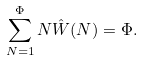<formula> <loc_0><loc_0><loc_500><loc_500>\sum _ { N = 1 } ^ { \Phi } N { \hat { W } } ( N ) = \Phi .</formula> 